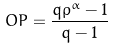<formula> <loc_0><loc_0><loc_500><loc_500>O P = \frac { q \rho ^ { \alpha } - 1 } { q - 1 }</formula> 